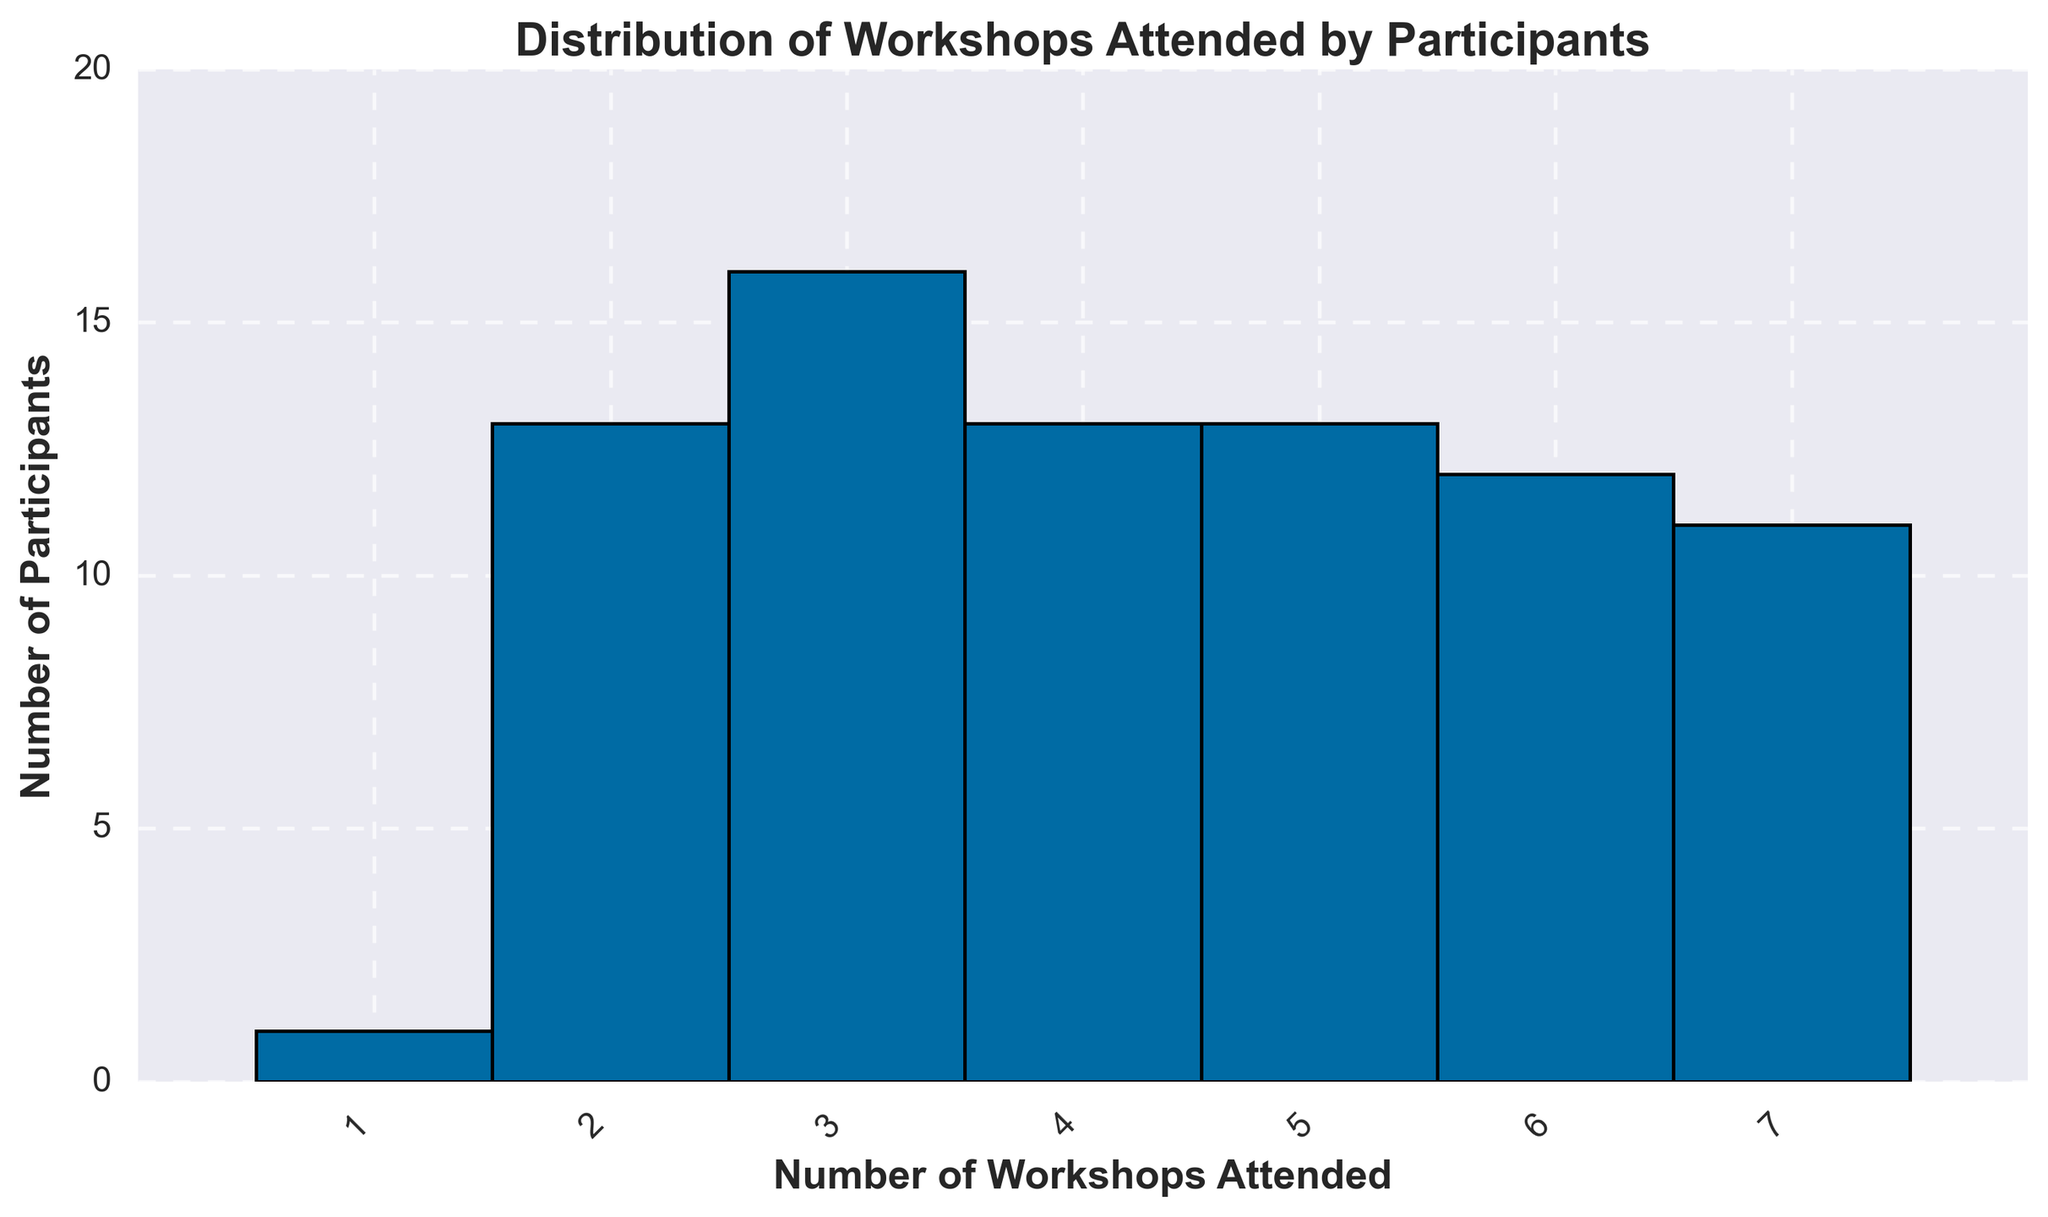How many participants attended exactly 5 workshops? First, identify the bin that corresponds to 5 workshops. The height of the bar at 5 workshops tells us how many participants attended exactly 5 workshops.
Answer: 13 What is the most common number of workshops attended? Find the bar with the greatest height. The x-axis label of this bar represents the most frequently attended number of workshops.
Answer: 3 How many participants attended fewer than 3 workshops in total? Sum the heights of the bars for workshops attended less than 3 (1 and 2 workshops).
Answer: 14 What is the total number of workshops attended by participants who went to exactly 6 workshops? Count the number of participants who attended 6 workshops and multiply by 6. There are 12 participants who attended 6 workshops. Thus, 12 x 6 = 72 workshops.
Answer: 72 Which is higher, the number of participants who attended 7 workshops or those who attended 2 workshops? Compare the heights of the bars at 7 and 2 workshops. The bar at 7 workshops is taller.
Answer: 7 workshops How many participants attended 2 or 4 workshops combined? Sum the heights of the bars at 2 workshops and 4 workshops. There are 10 participants who attended 2 workshops and 11 who attended 4 workshops. So, 10 + 11 = 21 participants.
Answer: 21 How many more participants attended 7 workshops than those who attended 1 workshop? Subtract the number of participants who attended 1 workshop from those who attended 7 workshops. This is 13 (7 workshops) - 1 (1 workshop) = 12.
Answer: 12 What is the range of workshops attended by the participants? Identify the minimum and maximum values on the x-axis and calculate the difference. The range is 8 (1 to 7 workshops).
Answer: 7 Which has a higher number of participants, those attending an odd number of workshops or an even number? Sum the number of participants for odd numbers (1, 3, 5, 7) and even numbers (2, 4, 6) separately and compare. Odd: 1+16+13+14=44, Even: 10+11+12=33. 44 > 33.
Answer: Odd What is the least attended number of workshops and how many participants attended it? Find the smallest bar on the histogram and check its height; this corresponds to the least attended number.
Answer: 1 workshop and 1 participant 